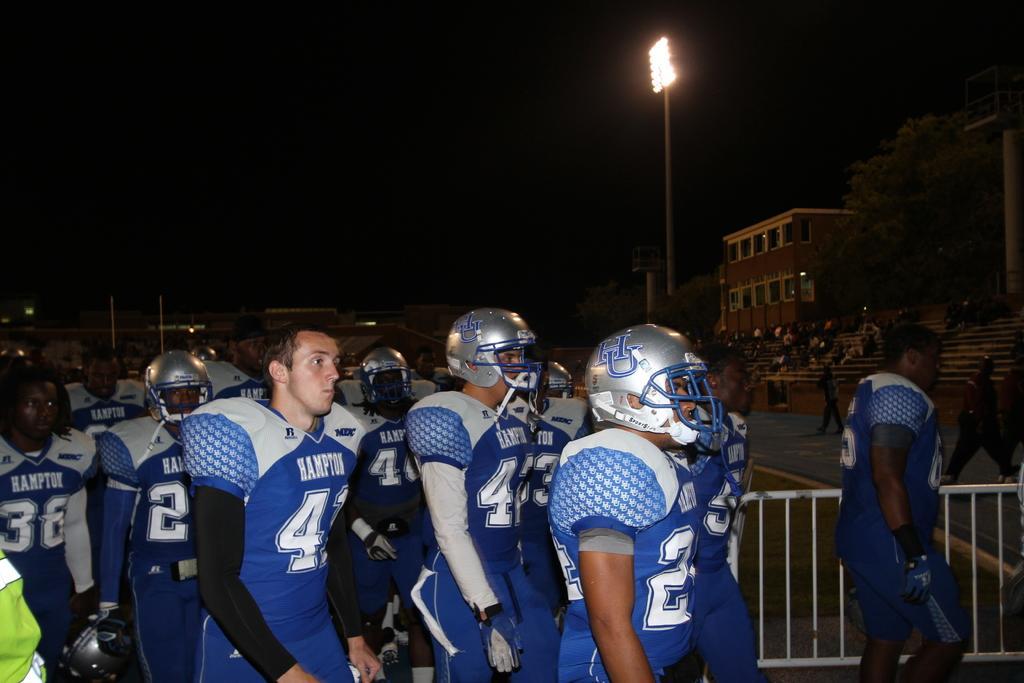In one or two sentences, can you explain what this image depicts? In this image in the foreground there are few peoples wearing helmets, fence visible, at the top there is the sky, in the middle there are buildings, poles, on the right side there is a building, tree, staircase, on which there few people. 